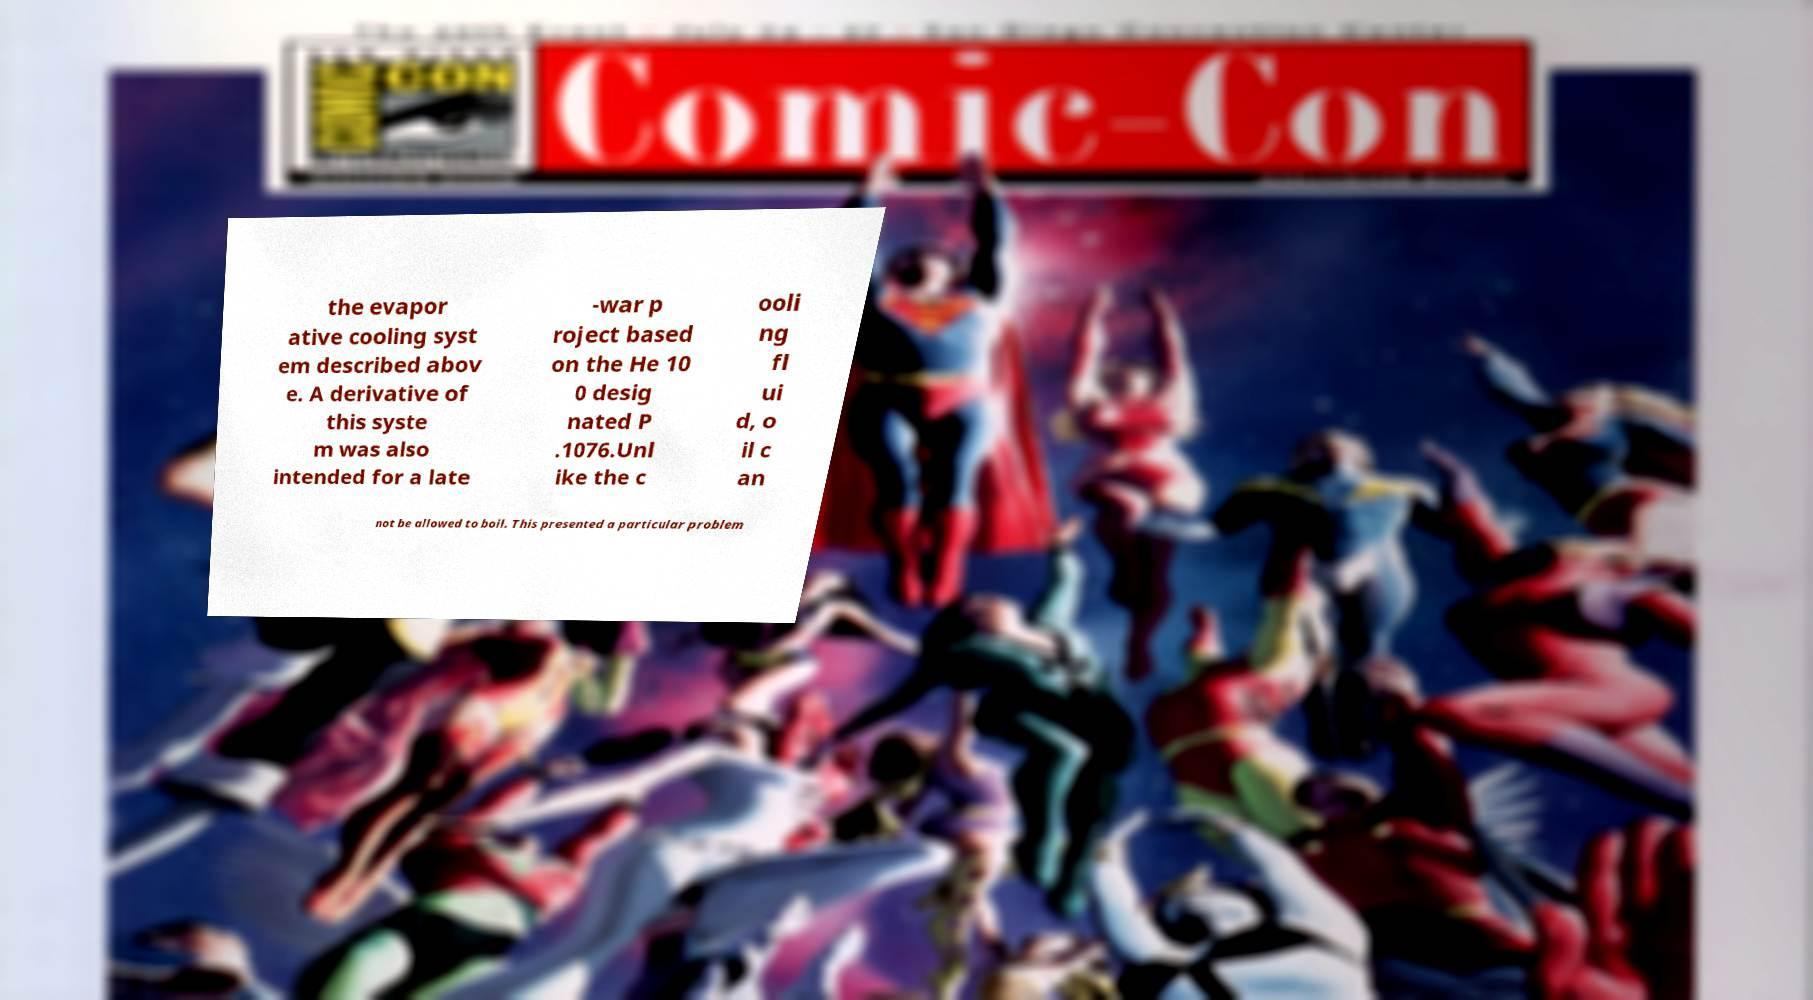I need the written content from this picture converted into text. Can you do that? the evapor ative cooling syst em described abov e. A derivative of this syste m was also intended for a late -war p roject based on the He 10 0 desig nated P .1076.Unl ike the c ooli ng fl ui d, o il c an not be allowed to boil. This presented a particular problem 